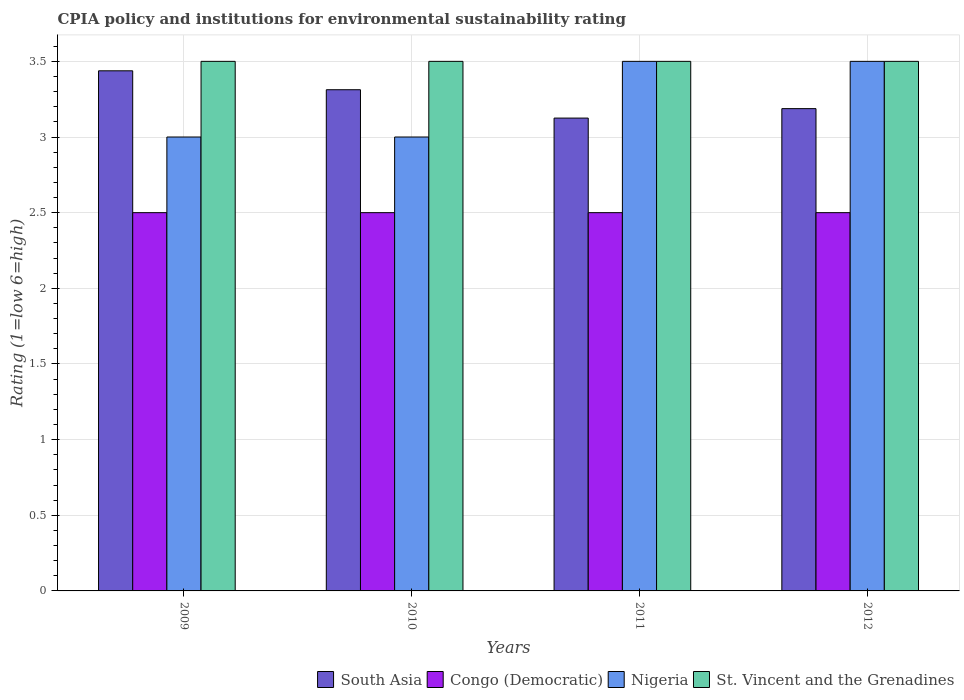Are the number of bars per tick equal to the number of legend labels?
Keep it short and to the point. Yes. How many bars are there on the 4th tick from the left?
Ensure brevity in your answer.  4. How many bars are there on the 4th tick from the right?
Give a very brief answer. 4. What is the label of the 4th group of bars from the left?
Offer a terse response. 2012. Across all years, what is the maximum CPIA rating in South Asia?
Ensure brevity in your answer.  3.44. What is the total CPIA rating in South Asia in the graph?
Offer a very short reply. 13.06. What is the difference between the CPIA rating in South Asia in 2011 and the CPIA rating in St. Vincent and the Grenadines in 2012?
Provide a succinct answer. -0.38. In the year 2012, what is the difference between the CPIA rating in Nigeria and CPIA rating in St. Vincent and the Grenadines?
Make the answer very short. 0. Is the CPIA rating in Congo (Democratic) in 2010 less than that in 2012?
Provide a succinct answer. No. What is the difference between the highest and the lowest CPIA rating in South Asia?
Make the answer very short. 0.31. What does the 2nd bar from the left in 2011 represents?
Your response must be concise. Congo (Democratic). What does the 1st bar from the right in 2012 represents?
Offer a terse response. St. Vincent and the Grenadines. How many bars are there?
Keep it short and to the point. 16. How many years are there in the graph?
Your answer should be compact. 4. Are the values on the major ticks of Y-axis written in scientific E-notation?
Provide a short and direct response. No. Where does the legend appear in the graph?
Provide a succinct answer. Bottom right. How are the legend labels stacked?
Your response must be concise. Horizontal. What is the title of the graph?
Ensure brevity in your answer.  CPIA policy and institutions for environmental sustainability rating. Does "Hong Kong" appear as one of the legend labels in the graph?
Ensure brevity in your answer.  No. What is the label or title of the X-axis?
Offer a very short reply. Years. What is the Rating (1=low 6=high) of South Asia in 2009?
Your response must be concise. 3.44. What is the Rating (1=low 6=high) in Nigeria in 2009?
Give a very brief answer. 3. What is the Rating (1=low 6=high) of South Asia in 2010?
Ensure brevity in your answer.  3.31. What is the Rating (1=low 6=high) in Nigeria in 2010?
Give a very brief answer. 3. What is the Rating (1=low 6=high) in St. Vincent and the Grenadines in 2010?
Provide a succinct answer. 3.5. What is the Rating (1=low 6=high) in South Asia in 2011?
Your answer should be compact. 3.12. What is the Rating (1=low 6=high) in Nigeria in 2011?
Give a very brief answer. 3.5. What is the Rating (1=low 6=high) of South Asia in 2012?
Offer a very short reply. 3.19. Across all years, what is the maximum Rating (1=low 6=high) of South Asia?
Your answer should be very brief. 3.44. Across all years, what is the maximum Rating (1=low 6=high) of Congo (Democratic)?
Ensure brevity in your answer.  2.5. Across all years, what is the maximum Rating (1=low 6=high) of Nigeria?
Your answer should be compact. 3.5. Across all years, what is the minimum Rating (1=low 6=high) in South Asia?
Offer a very short reply. 3.12. Across all years, what is the minimum Rating (1=low 6=high) of Nigeria?
Ensure brevity in your answer.  3. Across all years, what is the minimum Rating (1=low 6=high) in St. Vincent and the Grenadines?
Keep it short and to the point. 3.5. What is the total Rating (1=low 6=high) in South Asia in the graph?
Offer a very short reply. 13.06. What is the total Rating (1=low 6=high) in Nigeria in the graph?
Offer a very short reply. 13. What is the total Rating (1=low 6=high) of St. Vincent and the Grenadines in the graph?
Give a very brief answer. 14. What is the difference between the Rating (1=low 6=high) of South Asia in 2009 and that in 2010?
Your response must be concise. 0.12. What is the difference between the Rating (1=low 6=high) of South Asia in 2009 and that in 2011?
Provide a succinct answer. 0.31. What is the difference between the Rating (1=low 6=high) of South Asia in 2010 and that in 2011?
Keep it short and to the point. 0.19. What is the difference between the Rating (1=low 6=high) of Congo (Democratic) in 2010 and that in 2011?
Ensure brevity in your answer.  0. What is the difference between the Rating (1=low 6=high) in Nigeria in 2010 and that in 2011?
Provide a short and direct response. -0.5. What is the difference between the Rating (1=low 6=high) in Congo (Democratic) in 2010 and that in 2012?
Your answer should be very brief. 0. What is the difference between the Rating (1=low 6=high) of Nigeria in 2010 and that in 2012?
Give a very brief answer. -0.5. What is the difference between the Rating (1=low 6=high) in St. Vincent and the Grenadines in 2010 and that in 2012?
Your answer should be very brief. 0. What is the difference between the Rating (1=low 6=high) in South Asia in 2011 and that in 2012?
Your answer should be compact. -0.06. What is the difference between the Rating (1=low 6=high) in St. Vincent and the Grenadines in 2011 and that in 2012?
Your answer should be very brief. 0. What is the difference between the Rating (1=low 6=high) in South Asia in 2009 and the Rating (1=low 6=high) in Nigeria in 2010?
Your answer should be compact. 0.44. What is the difference between the Rating (1=low 6=high) of South Asia in 2009 and the Rating (1=low 6=high) of St. Vincent and the Grenadines in 2010?
Give a very brief answer. -0.06. What is the difference between the Rating (1=low 6=high) of Congo (Democratic) in 2009 and the Rating (1=low 6=high) of St. Vincent and the Grenadines in 2010?
Make the answer very short. -1. What is the difference between the Rating (1=low 6=high) of Nigeria in 2009 and the Rating (1=low 6=high) of St. Vincent and the Grenadines in 2010?
Keep it short and to the point. -0.5. What is the difference between the Rating (1=low 6=high) of South Asia in 2009 and the Rating (1=low 6=high) of Nigeria in 2011?
Keep it short and to the point. -0.06. What is the difference between the Rating (1=low 6=high) of South Asia in 2009 and the Rating (1=low 6=high) of St. Vincent and the Grenadines in 2011?
Ensure brevity in your answer.  -0.06. What is the difference between the Rating (1=low 6=high) of Congo (Democratic) in 2009 and the Rating (1=low 6=high) of St. Vincent and the Grenadines in 2011?
Provide a short and direct response. -1. What is the difference between the Rating (1=low 6=high) of South Asia in 2009 and the Rating (1=low 6=high) of Congo (Democratic) in 2012?
Keep it short and to the point. 0.94. What is the difference between the Rating (1=low 6=high) of South Asia in 2009 and the Rating (1=low 6=high) of Nigeria in 2012?
Provide a succinct answer. -0.06. What is the difference between the Rating (1=low 6=high) of South Asia in 2009 and the Rating (1=low 6=high) of St. Vincent and the Grenadines in 2012?
Provide a short and direct response. -0.06. What is the difference between the Rating (1=low 6=high) in Congo (Democratic) in 2009 and the Rating (1=low 6=high) in St. Vincent and the Grenadines in 2012?
Your answer should be compact. -1. What is the difference between the Rating (1=low 6=high) in Nigeria in 2009 and the Rating (1=low 6=high) in St. Vincent and the Grenadines in 2012?
Provide a succinct answer. -0.5. What is the difference between the Rating (1=low 6=high) of South Asia in 2010 and the Rating (1=low 6=high) of Congo (Democratic) in 2011?
Offer a very short reply. 0.81. What is the difference between the Rating (1=low 6=high) in South Asia in 2010 and the Rating (1=low 6=high) in Nigeria in 2011?
Your answer should be compact. -0.19. What is the difference between the Rating (1=low 6=high) of South Asia in 2010 and the Rating (1=low 6=high) of St. Vincent and the Grenadines in 2011?
Offer a very short reply. -0.19. What is the difference between the Rating (1=low 6=high) of South Asia in 2010 and the Rating (1=low 6=high) of Congo (Democratic) in 2012?
Your answer should be very brief. 0.81. What is the difference between the Rating (1=low 6=high) of South Asia in 2010 and the Rating (1=low 6=high) of Nigeria in 2012?
Ensure brevity in your answer.  -0.19. What is the difference between the Rating (1=low 6=high) of South Asia in 2010 and the Rating (1=low 6=high) of St. Vincent and the Grenadines in 2012?
Provide a short and direct response. -0.19. What is the difference between the Rating (1=low 6=high) in Congo (Democratic) in 2010 and the Rating (1=low 6=high) in Nigeria in 2012?
Your answer should be very brief. -1. What is the difference between the Rating (1=low 6=high) in Congo (Democratic) in 2010 and the Rating (1=low 6=high) in St. Vincent and the Grenadines in 2012?
Provide a succinct answer. -1. What is the difference between the Rating (1=low 6=high) of Nigeria in 2010 and the Rating (1=low 6=high) of St. Vincent and the Grenadines in 2012?
Provide a succinct answer. -0.5. What is the difference between the Rating (1=low 6=high) of South Asia in 2011 and the Rating (1=low 6=high) of Nigeria in 2012?
Provide a succinct answer. -0.38. What is the difference between the Rating (1=low 6=high) in South Asia in 2011 and the Rating (1=low 6=high) in St. Vincent and the Grenadines in 2012?
Your response must be concise. -0.38. What is the difference between the Rating (1=low 6=high) of Congo (Democratic) in 2011 and the Rating (1=low 6=high) of Nigeria in 2012?
Your response must be concise. -1. What is the difference between the Rating (1=low 6=high) of Nigeria in 2011 and the Rating (1=low 6=high) of St. Vincent and the Grenadines in 2012?
Offer a terse response. 0. What is the average Rating (1=low 6=high) in South Asia per year?
Offer a terse response. 3.27. What is the average Rating (1=low 6=high) of St. Vincent and the Grenadines per year?
Make the answer very short. 3.5. In the year 2009, what is the difference between the Rating (1=low 6=high) of South Asia and Rating (1=low 6=high) of Congo (Democratic)?
Ensure brevity in your answer.  0.94. In the year 2009, what is the difference between the Rating (1=low 6=high) of South Asia and Rating (1=low 6=high) of Nigeria?
Your answer should be compact. 0.44. In the year 2009, what is the difference between the Rating (1=low 6=high) of South Asia and Rating (1=low 6=high) of St. Vincent and the Grenadines?
Your answer should be compact. -0.06. In the year 2009, what is the difference between the Rating (1=low 6=high) of Congo (Democratic) and Rating (1=low 6=high) of Nigeria?
Keep it short and to the point. -0.5. In the year 2009, what is the difference between the Rating (1=low 6=high) in Congo (Democratic) and Rating (1=low 6=high) in St. Vincent and the Grenadines?
Provide a short and direct response. -1. In the year 2009, what is the difference between the Rating (1=low 6=high) of Nigeria and Rating (1=low 6=high) of St. Vincent and the Grenadines?
Ensure brevity in your answer.  -0.5. In the year 2010, what is the difference between the Rating (1=low 6=high) of South Asia and Rating (1=low 6=high) of Congo (Democratic)?
Your answer should be compact. 0.81. In the year 2010, what is the difference between the Rating (1=low 6=high) in South Asia and Rating (1=low 6=high) in Nigeria?
Provide a short and direct response. 0.31. In the year 2010, what is the difference between the Rating (1=low 6=high) of South Asia and Rating (1=low 6=high) of St. Vincent and the Grenadines?
Provide a short and direct response. -0.19. In the year 2010, what is the difference between the Rating (1=low 6=high) of Congo (Democratic) and Rating (1=low 6=high) of Nigeria?
Make the answer very short. -0.5. In the year 2010, what is the difference between the Rating (1=low 6=high) of Congo (Democratic) and Rating (1=low 6=high) of St. Vincent and the Grenadines?
Offer a terse response. -1. In the year 2010, what is the difference between the Rating (1=low 6=high) in Nigeria and Rating (1=low 6=high) in St. Vincent and the Grenadines?
Keep it short and to the point. -0.5. In the year 2011, what is the difference between the Rating (1=low 6=high) of South Asia and Rating (1=low 6=high) of Nigeria?
Your answer should be compact. -0.38. In the year 2011, what is the difference between the Rating (1=low 6=high) of South Asia and Rating (1=low 6=high) of St. Vincent and the Grenadines?
Your answer should be very brief. -0.38. In the year 2011, what is the difference between the Rating (1=low 6=high) of Congo (Democratic) and Rating (1=low 6=high) of Nigeria?
Offer a terse response. -1. In the year 2011, what is the difference between the Rating (1=low 6=high) of Congo (Democratic) and Rating (1=low 6=high) of St. Vincent and the Grenadines?
Your answer should be very brief. -1. In the year 2012, what is the difference between the Rating (1=low 6=high) of South Asia and Rating (1=low 6=high) of Congo (Democratic)?
Your answer should be very brief. 0.69. In the year 2012, what is the difference between the Rating (1=low 6=high) of South Asia and Rating (1=low 6=high) of Nigeria?
Keep it short and to the point. -0.31. In the year 2012, what is the difference between the Rating (1=low 6=high) of South Asia and Rating (1=low 6=high) of St. Vincent and the Grenadines?
Offer a terse response. -0.31. In the year 2012, what is the difference between the Rating (1=low 6=high) in Congo (Democratic) and Rating (1=low 6=high) in Nigeria?
Give a very brief answer. -1. In the year 2012, what is the difference between the Rating (1=low 6=high) in Nigeria and Rating (1=low 6=high) in St. Vincent and the Grenadines?
Give a very brief answer. 0. What is the ratio of the Rating (1=low 6=high) in South Asia in 2009 to that in 2010?
Ensure brevity in your answer.  1.04. What is the ratio of the Rating (1=low 6=high) in Nigeria in 2009 to that in 2010?
Provide a succinct answer. 1. What is the ratio of the Rating (1=low 6=high) of South Asia in 2009 to that in 2011?
Keep it short and to the point. 1.1. What is the ratio of the Rating (1=low 6=high) in St. Vincent and the Grenadines in 2009 to that in 2011?
Ensure brevity in your answer.  1. What is the ratio of the Rating (1=low 6=high) in South Asia in 2009 to that in 2012?
Provide a succinct answer. 1.08. What is the ratio of the Rating (1=low 6=high) of Congo (Democratic) in 2009 to that in 2012?
Keep it short and to the point. 1. What is the ratio of the Rating (1=low 6=high) of St. Vincent and the Grenadines in 2009 to that in 2012?
Provide a succinct answer. 1. What is the ratio of the Rating (1=low 6=high) of South Asia in 2010 to that in 2011?
Provide a short and direct response. 1.06. What is the ratio of the Rating (1=low 6=high) of Congo (Democratic) in 2010 to that in 2011?
Ensure brevity in your answer.  1. What is the ratio of the Rating (1=low 6=high) in Nigeria in 2010 to that in 2011?
Offer a terse response. 0.86. What is the ratio of the Rating (1=low 6=high) in St. Vincent and the Grenadines in 2010 to that in 2011?
Provide a succinct answer. 1. What is the ratio of the Rating (1=low 6=high) of South Asia in 2010 to that in 2012?
Offer a very short reply. 1.04. What is the ratio of the Rating (1=low 6=high) in South Asia in 2011 to that in 2012?
Keep it short and to the point. 0.98. What is the ratio of the Rating (1=low 6=high) in Congo (Democratic) in 2011 to that in 2012?
Provide a short and direct response. 1. What is the ratio of the Rating (1=low 6=high) in Nigeria in 2011 to that in 2012?
Provide a short and direct response. 1. What is the ratio of the Rating (1=low 6=high) in St. Vincent and the Grenadines in 2011 to that in 2012?
Your answer should be compact. 1. What is the difference between the highest and the second highest Rating (1=low 6=high) in St. Vincent and the Grenadines?
Offer a very short reply. 0. What is the difference between the highest and the lowest Rating (1=low 6=high) of South Asia?
Offer a very short reply. 0.31. What is the difference between the highest and the lowest Rating (1=low 6=high) of Congo (Democratic)?
Offer a very short reply. 0. What is the difference between the highest and the lowest Rating (1=low 6=high) of Nigeria?
Your answer should be very brief. 0.5. 